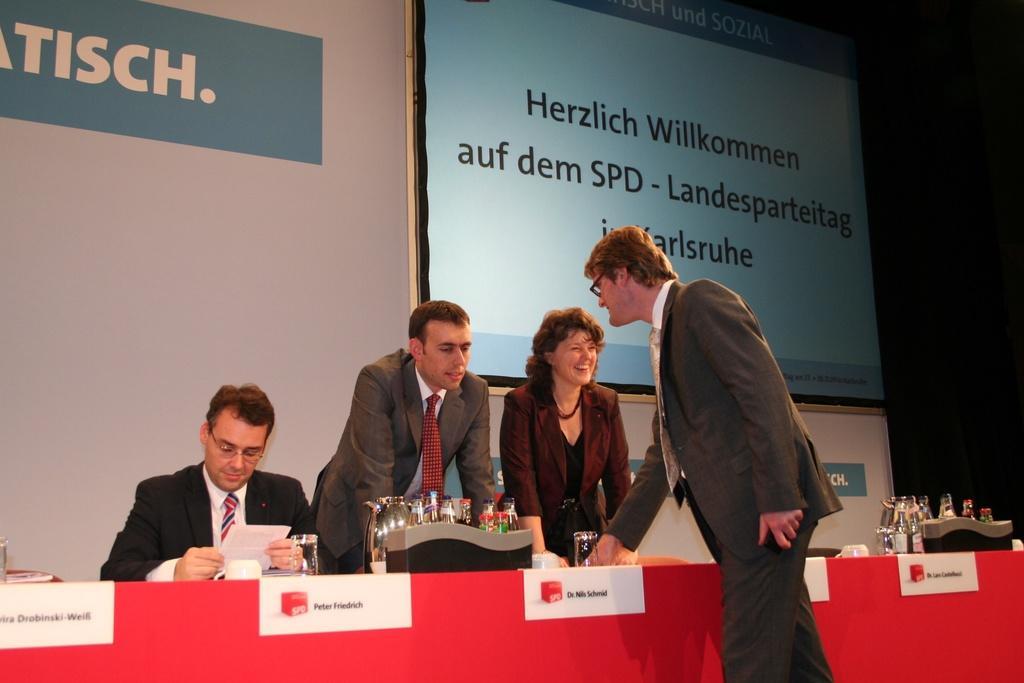Please provide a concise description of this image. In this image there are few persons around the table in which one of them is sitting on the chair, on the table there are few glasses, bottles and some other objects, there are is a screen with some text and some text on the wall. 